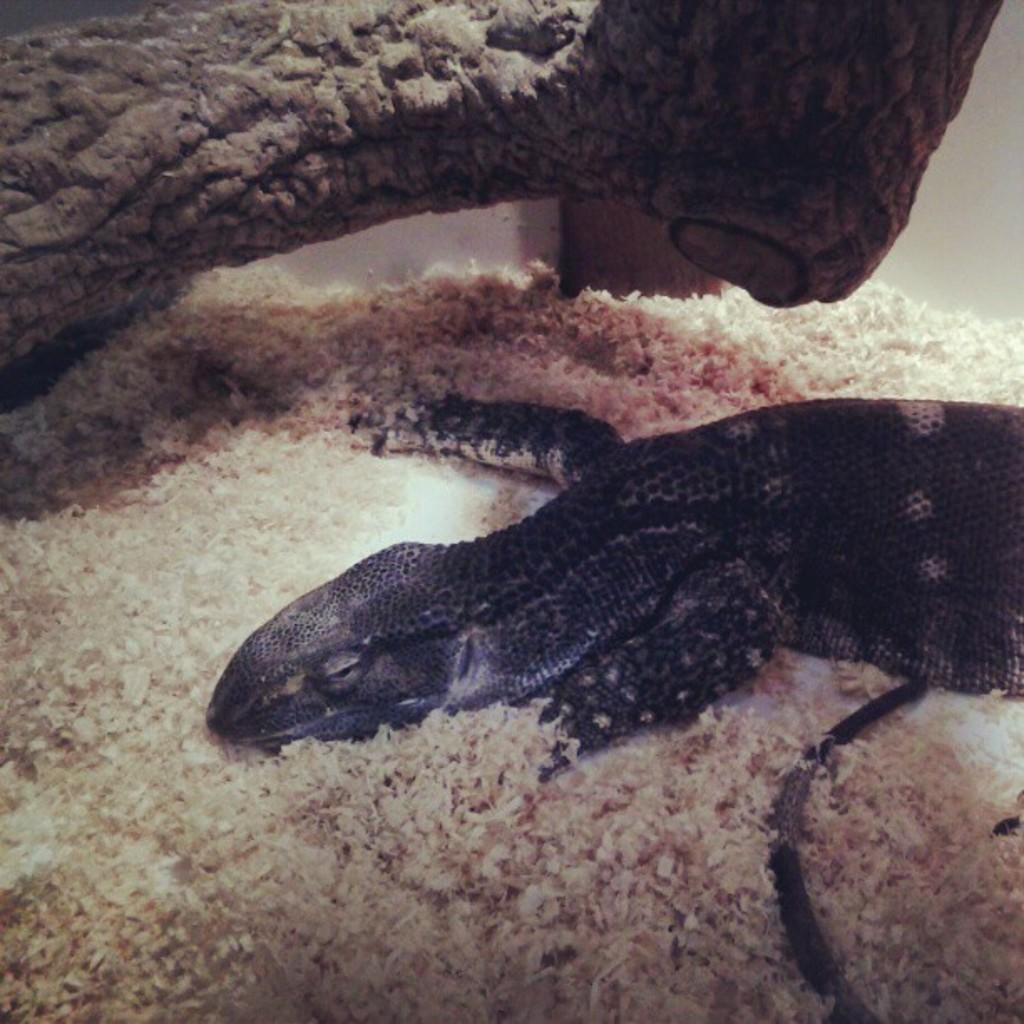What type of animal can be seen in the image? There is a reptile in the image. What is the reptile sitting on or near in the image? There is a wooden branch in the image. What is the reptile's current financial situation in the image? There is no information about the reptile's financial situation in the image. 